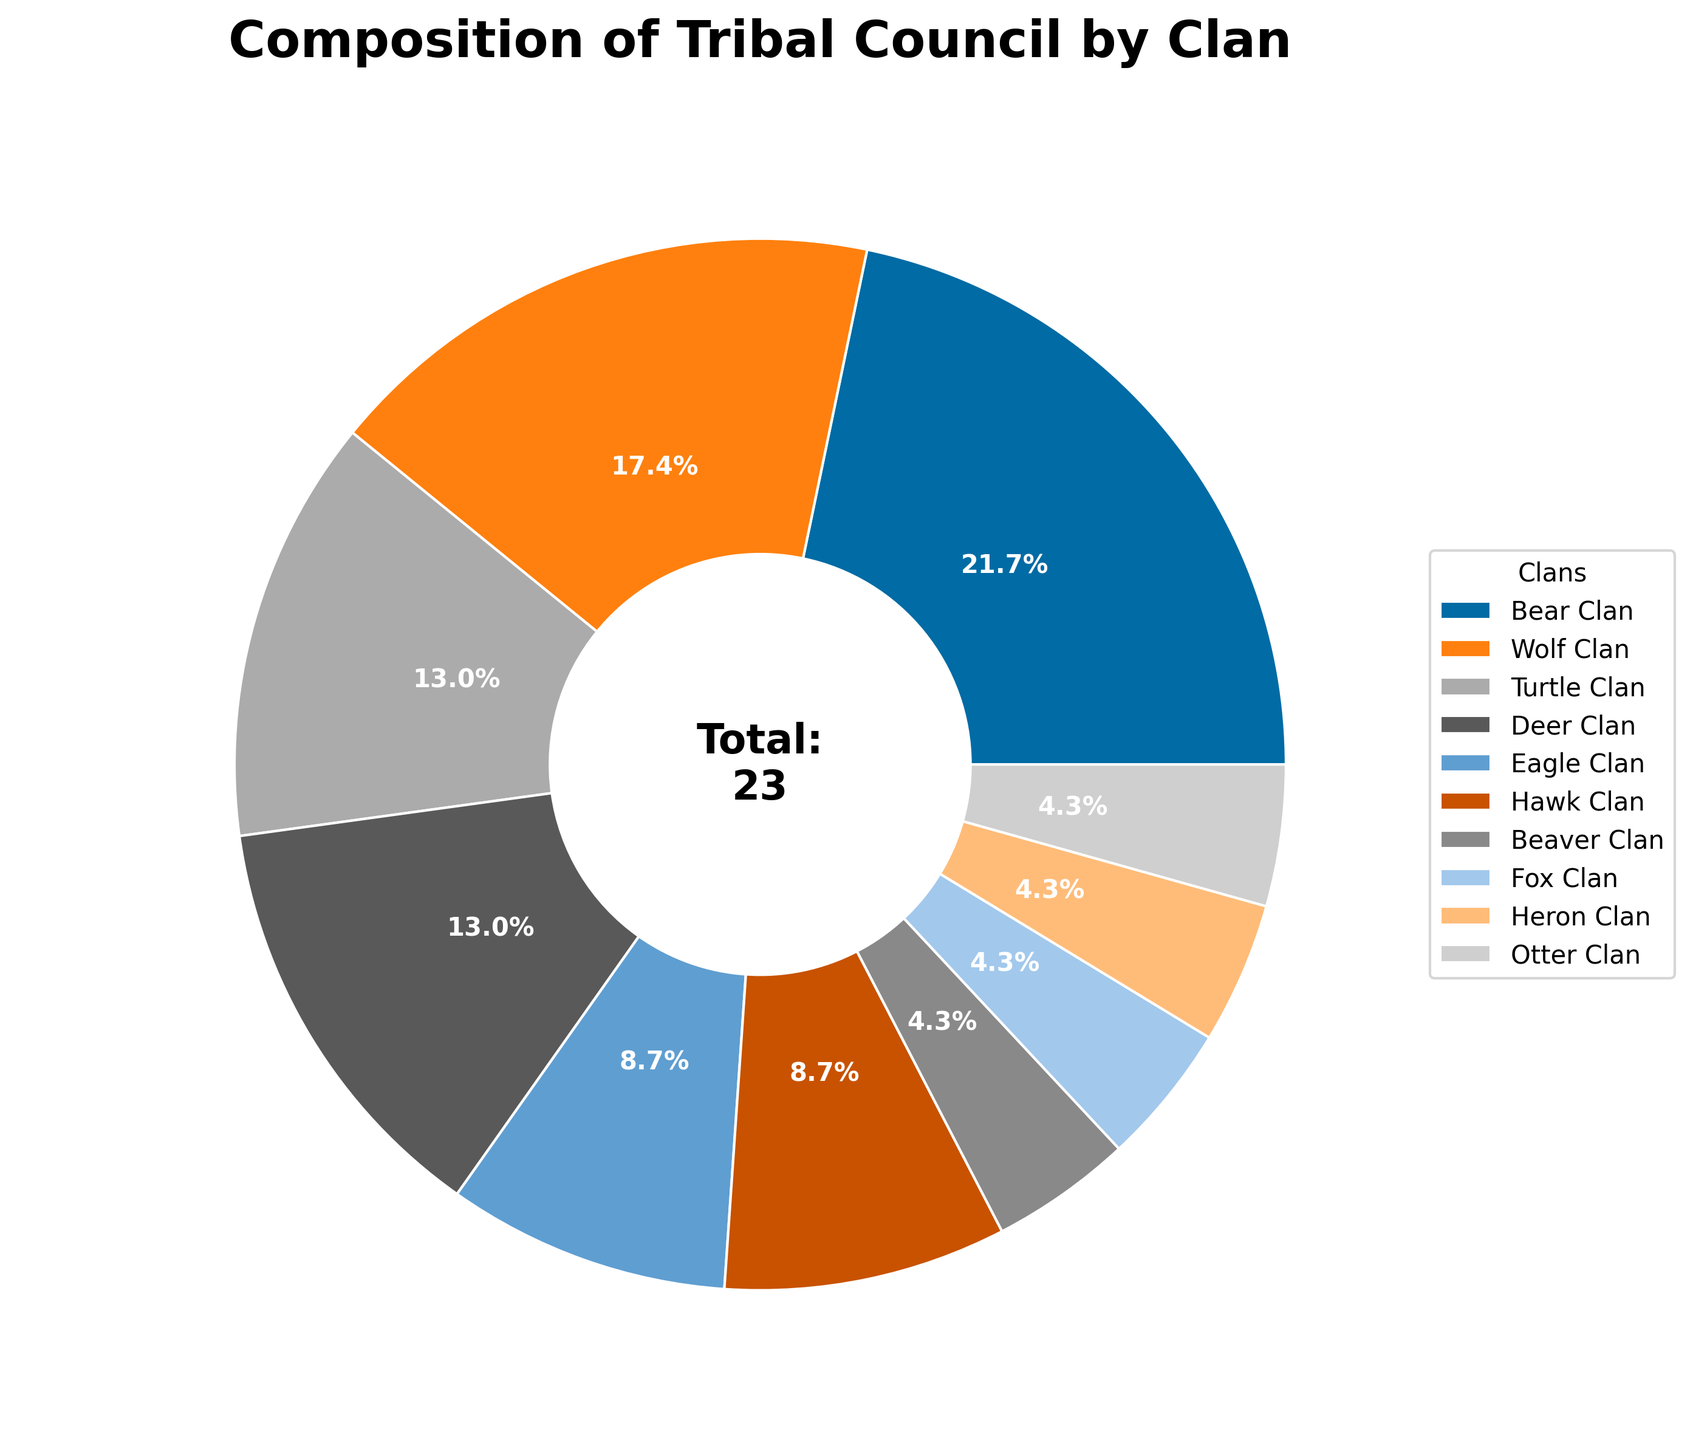What is the most represented clan in the tribal council? By looking at the pie chart, the Bear Clan has the largest wedge, indicating that it has the most representatives.
Answer: Bear Clan Which clan has more representatives, Turtle Clan or Deer Clan? By comparing the sizes of the wedges, the Turtle Clan and Deer Clan have the same size, meaning they have the same number of representatives.
Answer: Same How many clans have exactly one representative? From the pie chart labels, the Beaver Clan, Fox Clan, Heron Clan, and Otter Clan each have one representative. Counting these clans gives us 4.
Answer: 4 What percentage of the council is represented by the Wolf Clan and Turtle Clan combined? The pie chart shows that the Wolf Clan has 4 representatives, and the Turtle Clan has 3. Together, this is 7 out of the total 23 representatives. Calculating the percentage: (7/23) * 100 ≈ 30.4%.
Answer: 30.4% Which two clans have equal representation and what is their combined percentage of the council? From the pie chart, the Turtle Clan and Deer Clan both have 3 representatives. Combining these, we get 6 representatives out of 23. Calculating the percentage: (6/23) * 100 ≈ 26.1%.
Answer: Turtle Clan and Deer Clan, 26.1% What is the total number of representatives in the tribal council? The total number is given by summing the representatives of all the clans shown in the pie chart. Summing these up: 5 + 4 + 3 + 3 + 2 + 2 + 1 + 1 + 1 + 1 = 23.
Answer: 23 How does the representation of the Eagle Clan compare to that of the Hawk Clan? By observing the pie chart, the Eagle Clan and Hawk Clan have wedges of equal size, meaning they both have the same number of representatives.
Answer: Equal Which clans have fewer representatives than the Deer Clan? The Deer Clan has 3 representatives. The clans with fewer representatives are Eagle Clan, Hawk Clan, Beaver Clan, Fox Clan, Heron Clan, and Otter Clan.
Answer: 6 clans (Eagle Clan, Hawk Clan, Beaver Clan, Fox Clan, Heron Clan, Otter Clan) What is the ratio of Bear Clan representatives to Otter Clan representatives? The pie chart shows that the Bear Clan has 5 representatives and the Otter Clan has 1. The ratio is 5:1.
Answer: 5:1 What is the combined representation percentage for the Hawk Clan and Fox Clan? The pie chart indicates that the Hawk Clan has 2 representatives and the Fox Clan has 1. Together, this is 3 out of 23. Calculating the percentage: (3/23) * 100 ≈ 13%.
Answer: 13% 